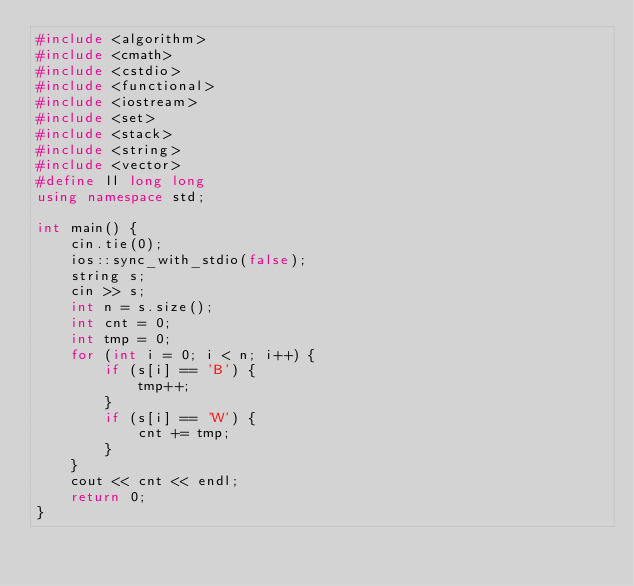<code> <loc_0><loc_0><loc_500><loc_500><_C++_>#include <algorithm>
#include <cmath>
#include <cstdio>
#include <functional>
#include <iostream>
#include <set>
#include <stack>
#include <string>
#include <vector>
#define ll long long
using namespace std;

int main() {
    cin.tie(0);
    ios::sync_with_stdio(false);
    string s;
    cin >> s;
    int n = s.size();
    int cnt = 0;
    int tmp = 0;
    for (int i = 0; i < n; i++) {
        if (s[i] == 'B') {
            tmp++;
        }
        if (s[i] == 'W') {
            cnt += tmp;
        }
    }
    cout << cnt << endl;
    return 0;
}</code> 